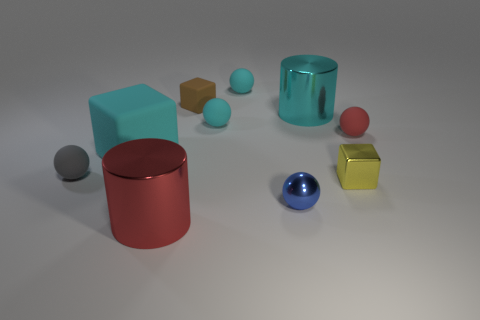What is the small cyan sphere in front of the cyan shiny object made of?
Ensure brevity in your answer.  Rubber. Do the cyan shiny cylinder and the red rubber thing have the same size?
Make the answer very short. No. How many other objects are there of the same size as the gray matte object?
Your answer should be very brief. 6. Is the color of the small metal block the same as the big matte block?
Ensure brevity in your answer.  No. What shape is the cyan rubber thing in front of the ball on the right side of the cylinder that is behind the small yellow object?
Your answer should be very brief. Cube. How many things are shiny cylinders in front of the tiny shiny cube or big metal objects that are to the left of the cyan shiny cylinder?
Give a very brief answer. 1. How big is the cylinder behind the metallic cylinder that is in front of the blue metallic object?
Your response must be concise. Large. There is a sphere to the right of the small metal ball; is its color the same as the tiny metallic ball?
Provide a succinct answer. No. Are there any small purple things of the same shape as the gray matte object?
Your answer should be compact. No. The shiny object that is the same size as the blue ball is what color?
Provide a succinct answer. Yellow. 